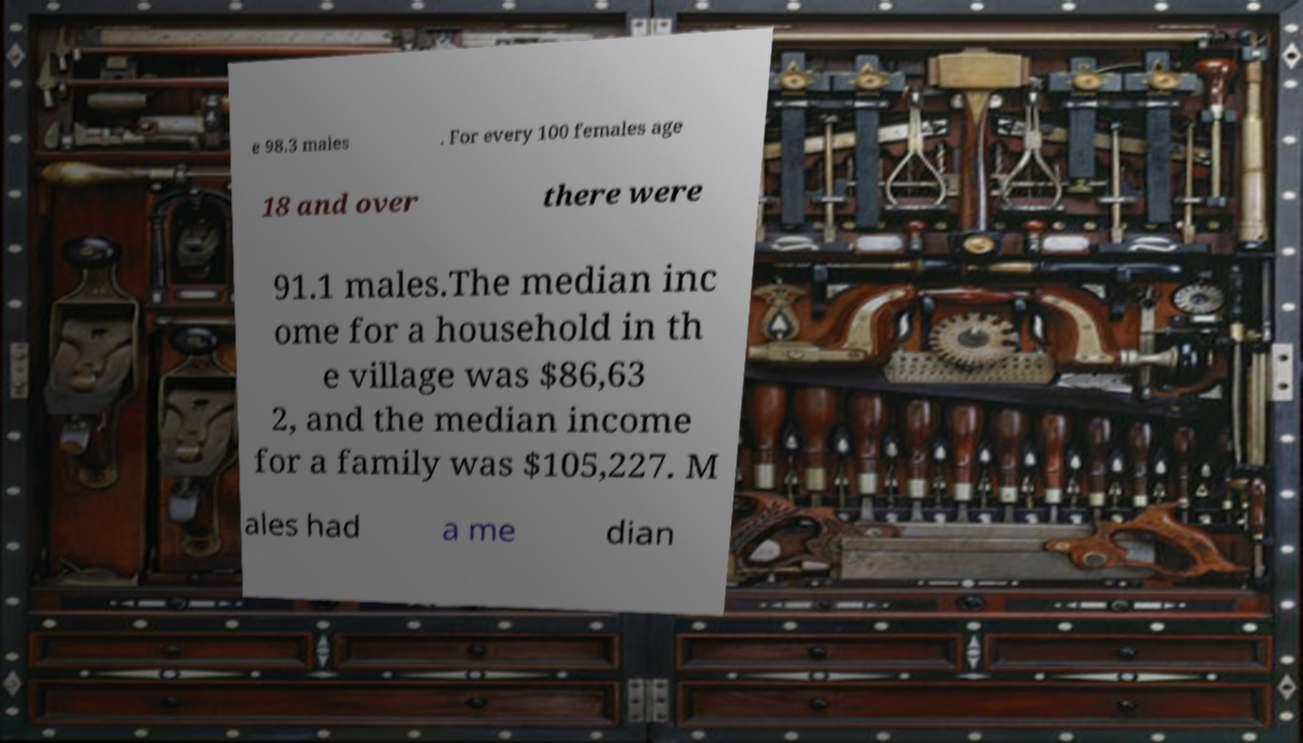Can you accurately transcribe the text from the provided image for me? e 98.3 males . For every 100 females age 18 and over there were 91.1 males.The median inc ome for a household in th e village was $86,63 2, and the median income for a family was $105,227. M ales had a me dian 